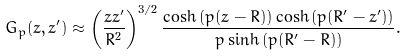<formula> <loc_0><loc_0><loc_500><loc_500>G _ { p } ( z , z ^ { \prime } ) \approx \left ( \frac { z z ^ { \prime } } { R ^ { 2 } } \right ) ^ { 3 / 2 } \frac { \cosh { ( p ( z - R ) ) } \cosh { ( p ( R ^ { \prime } - z ^ { \prime } ) ) } } { p \sinh { ( p ( R ^ { \prime } - R ) ) } } .</formula> 